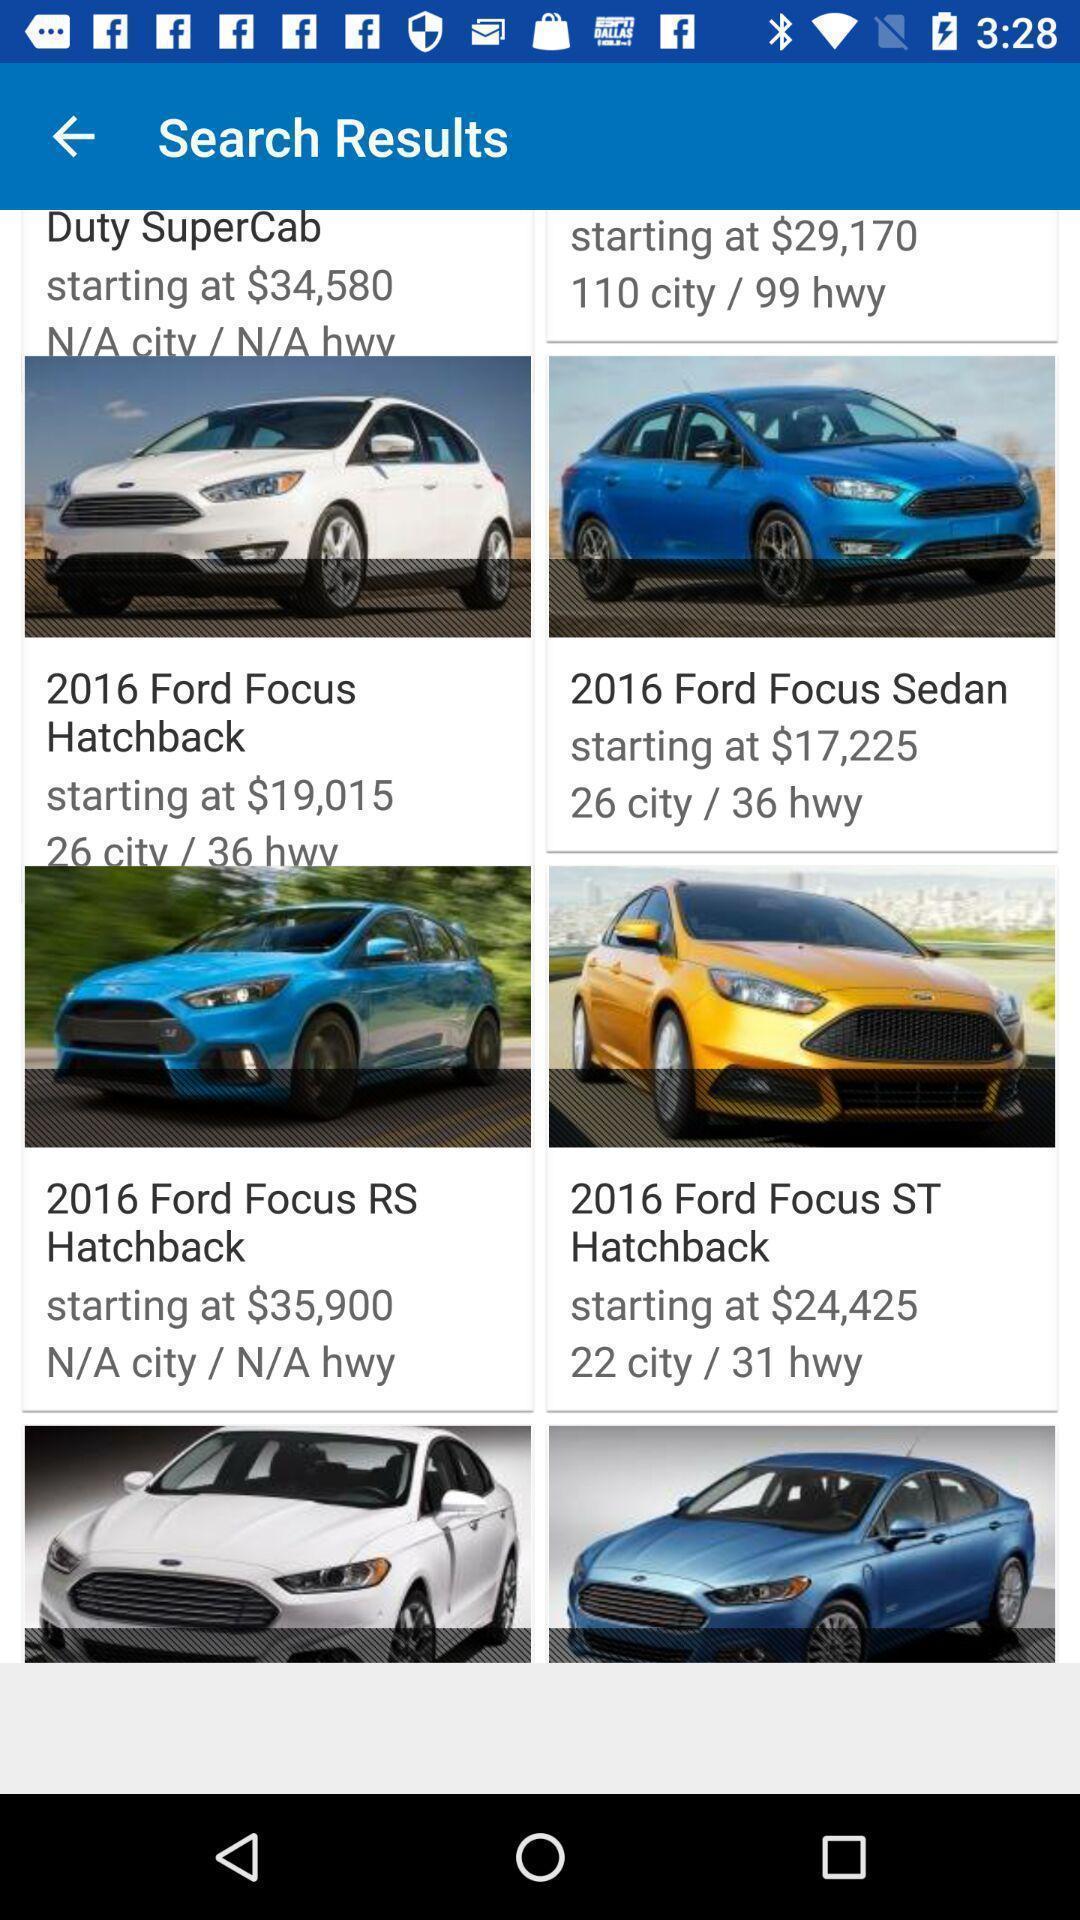Describe the content in this image. Page showing search results for ford focus. 